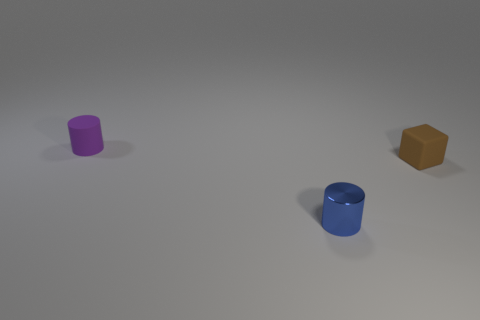Add 3 blue matte cylinders. How many objects exist? 6 Subtract all cubes. How many objects are left? 2 Add 1 small blue cylinders. How many small blue cylinders exist? 2 Subtract 0 yellow cylinders. How many objects are left? 3 Subtract all purple cubes. Subtract all rubber cylinders. How many objects are left? 2 Add 3 metal objects. How many metal objects are left? 4 